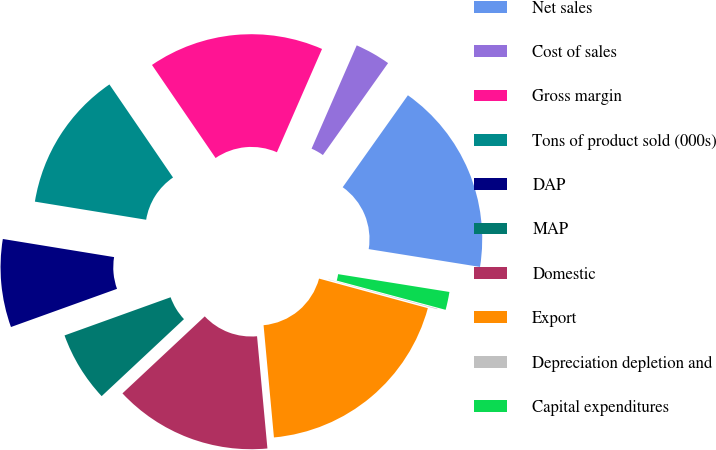Convert chart. <chart><loc_0><loc_0><loc_500><loc_500><pie_chart><fcel>Net sales<fcel>Cost of sales<fcel>Gross margin<fcel>Tons of product sold (000s)<fcel>DAP<fcel>MAP<fcel>Domestic<fcel>Export<fcel>Depreciation depletion and<fcel>Capital expenditures<nl><fcel>17.71%<fcel>3.26%<fcel>16.1%<fcel>12.89%<fcel>8.07%<fcel>6.47%<fcel>14.5%<fcel>19.31%<fcel>0.05%<fcel>1.65%<nl></chart> 